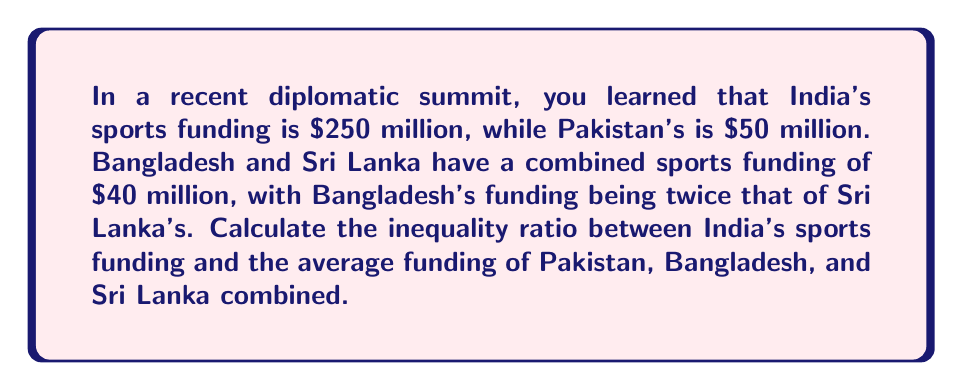Can you answer this question? Let's approach this step-by-step:

1) First, we need to calculate Bangladesh's and Sri Lanka's individual funding:
   Let $x$ be Sri Lanka's funding and $2x$ be Bangladesh's funding.
   $x + 2x = 40$ million
   $3x = 40$ million
   $x = \frac{40}{3}$ million

   So, Sri Lanka's funding = $\frac{40}{3}$ million
   Bangladesh's funding = $2 \cdot \frac{40}{3} = \frac{80}{3}$ million

2) Now, let's sum up the funding for Pakistan, Bangladesh, and Sri Lanka:
   $50 + \frac{80}{3} + \frac{40}{3} = 50 + \frac{120}{3} = 50 + 40 = 90$ million

3) Calculate the average funding of these three countries:
   $\frac{90}{3} = 30$ million

4) Now, we can calculate the inequality ratio:
   $\frac{\text{India's funding}}{\text{Average funding of others}} = \frac{250}{30} = \frac{25}{3}$

This ratio indicates that India's sports funding is $\frac{25}{3}$ times the average funding of Pakistan, Bangladesh, and Sri Lanka combined.
Answer: $\frac{25}{3}$ 